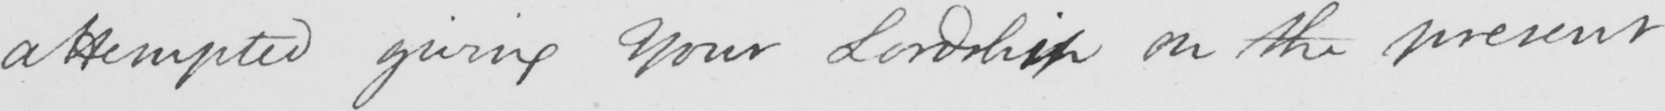Please provide the text content of this handwritten line. attempted giving Your Lordship on the present 